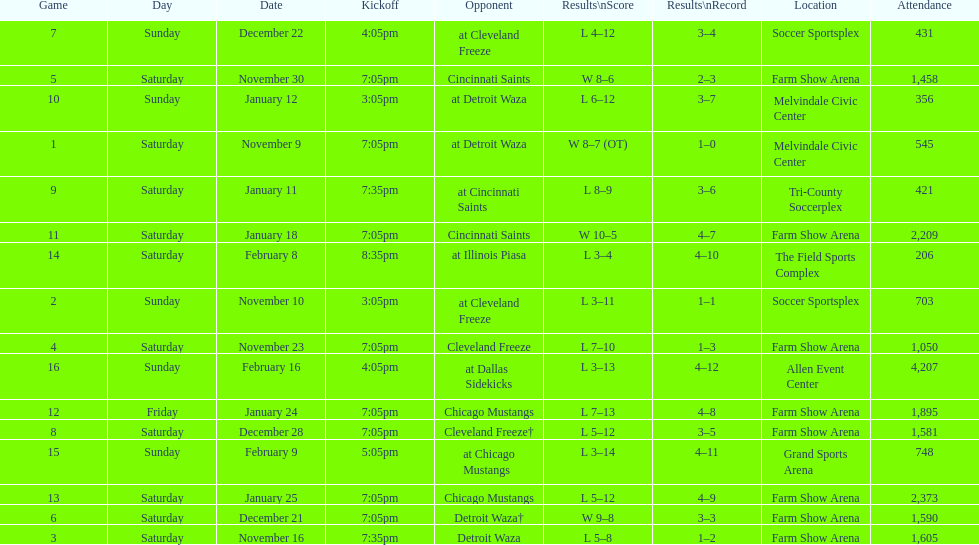Who was the first opponent on this list? Detroit Waza. Help me parse the entirety of this table. {'header': ['Game', 'Day', 'Date', 'Kickoff', 'Opponent', 'Results\\nScore', 'Results\\nRecord', 'Location', 'Attendance'], 'rows': [['7', 'Sunday', 'December 22', '4:05pm', 'at Cleveland Freeze', 'L 4–12', '3–4', 'Soccer Sportsplex', '431'], ['5', 'Saturday', 'November 30', '7:05pm', 'Cincinnati Saints', 'W 8–6', '2–3', 'Farm Show Arena', '1,458'], ['10', 'Sunday', 'January 12', '3:05pm', 'at Detroit Waza', 'L 6–12', '3–7', 'Melvindale Civic Center', '356'], ['1', 'Saturday', 'November 9', '7:05pm', 'at Detroit Waza', 'W 8–7 (OT)', '1–0', 'Melvindale Civic Center', '545'], ['9', 'Saturday', 'January 11', '7:35pm', 'at Cincinnati Saints', 'L 8–9', '3–6', 'Tri-County Soccerplex', '421'], ['11', 'Saturday', 'January 18', '7:05pm', 'Cincinnati Saints', 'W 10–5', '4–7', 'Farm Show Arena', '2,209'], ['14', 'Saturday', 'February 8', '8:35pm', 'at Illinois Piasa', 'L 3–4', '4–10', 'The Field Sports Complex', '206'], ['2', 'Sunday', 'November 10', '3:05pm', 'at Cleveland Freeze', 'L 3–11', '1–1', 'Soccer Sportsplex', '703'], ['4', 'Saturday', 'November 23', '7:05pm', 'Cleveland Freeze', 'L 7–10', '1–3', 'Farm Show Arena', '1,050'], ['16', 'Sunday', 'February 16', '4:05pm', 'at Dallas Sidekicks', 'L 3–13', '4–12', 'Allen Event Center', '4,207'], ['12', 'Friday', 'January 24', '7:05pm', 'Chicago Mustangs', 'L 7–13', '4–8', 'Farm Show Arena', '1,895'], ['8', 'Saturday', 'December 28', '7:05pm', 'Cleveland Freeze†', 'L 5–12', '3–5', 'Farm Show Arena', '1,581'], ['15', 'Sunday', 'February 9', '5:05pm', 'at Chicago Mustangs', 'L 3–14', '4–11', 'Grand Sports Arena', '748'], ['13', 'Saturday', 'January 25', '7:05pm', 'Chicago Mustangs', 'L 5–12', '4–9', 'Farm Show Arena', '2,373'], ['6', 'Saturday', 'December 21', '7:05pm', 'Detroit Waza†', 'W 9–8', '3–3', 'Farm Show Arena', '1,590'], ['3', 'Saturday', 'November 16', '7:35pm', 'Detroit Waza', 'L 5–8', '1–2', 'Farm Show Arena', '1,605']]} 